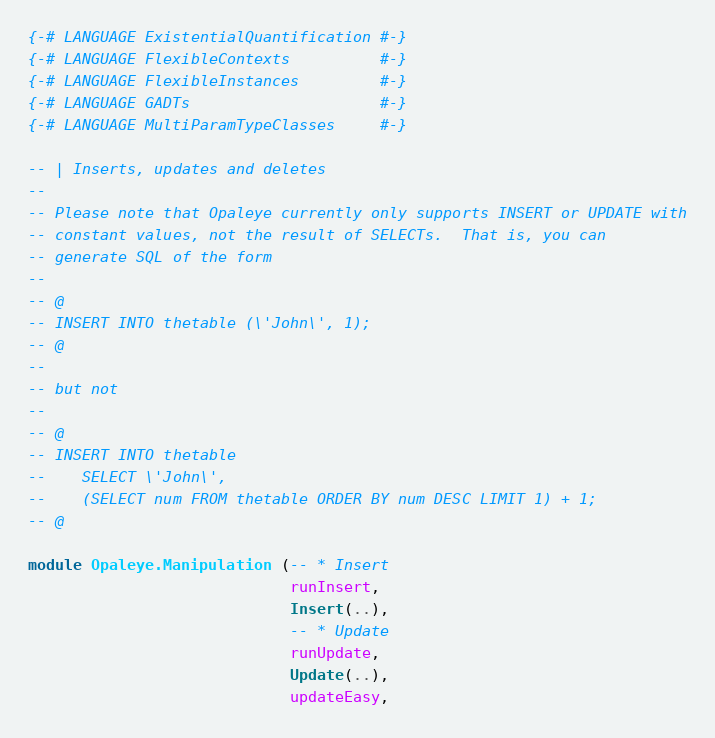<code> <loc_0><loc_0><loc_500><loc_500><_Haskell_>{-# LANGUAGE ExistentialQuantification #-}
{-# LANGUAGE FlexibleContexts          #-}
{-# LANGUAGE FlexibleInstances         #-}
{-# LANGUAGE GADTs                     #-}
{-# LANGUAGE MultiParamTypeClasses     #-}

-- | Inserts, updates and deletes
--
-- Please note that Opaleye currently only supports INSERT or UPDATE with
-- constant values, not the result of SELECTs.  That is, you can
-- generate SQL of the form
--
-- @
-- INSERT INTO thetable (\'John\', 1);
-- @
--
-- but not
--
-- @
-- INSERT INTO thetable
--    SELECT \'John\',
--    (SELECT num FROM thetable ORDER BY num DESC LIMIT 1) + 1;
-- @

module Opaleye.Manipulation (-- * Insert
                             runInsert,
                             Insert(..),
                             -- * Update
                             runUpdate,
                             Update(..),
                             updateEasy,</code> 